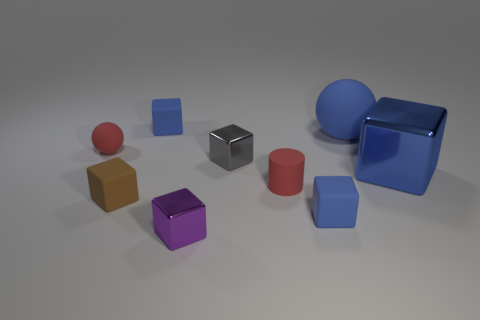Subtract all purple cylinders. How many blue cubes are left? 3 Subtract all purple blocks. How many blocks are left? 5 Subtract all blue matte blocks. How many blocks are left? 4 Subtract all brown blocks. Subtract all cyan cylinders. How many blocks are left? 5 Subtract all blocks. How many objects are left? 3 Subtract all large yellow rubber blocks. Subtract all large spheres. How many objects are left? 8 Add 8 tiny rubber spheres. How many tiny rubber spheres are left? 9 Add 3 tiny matte things. How many tiny matte things exist? 8 Subtract 1 red balls. How many objects are left? 8 